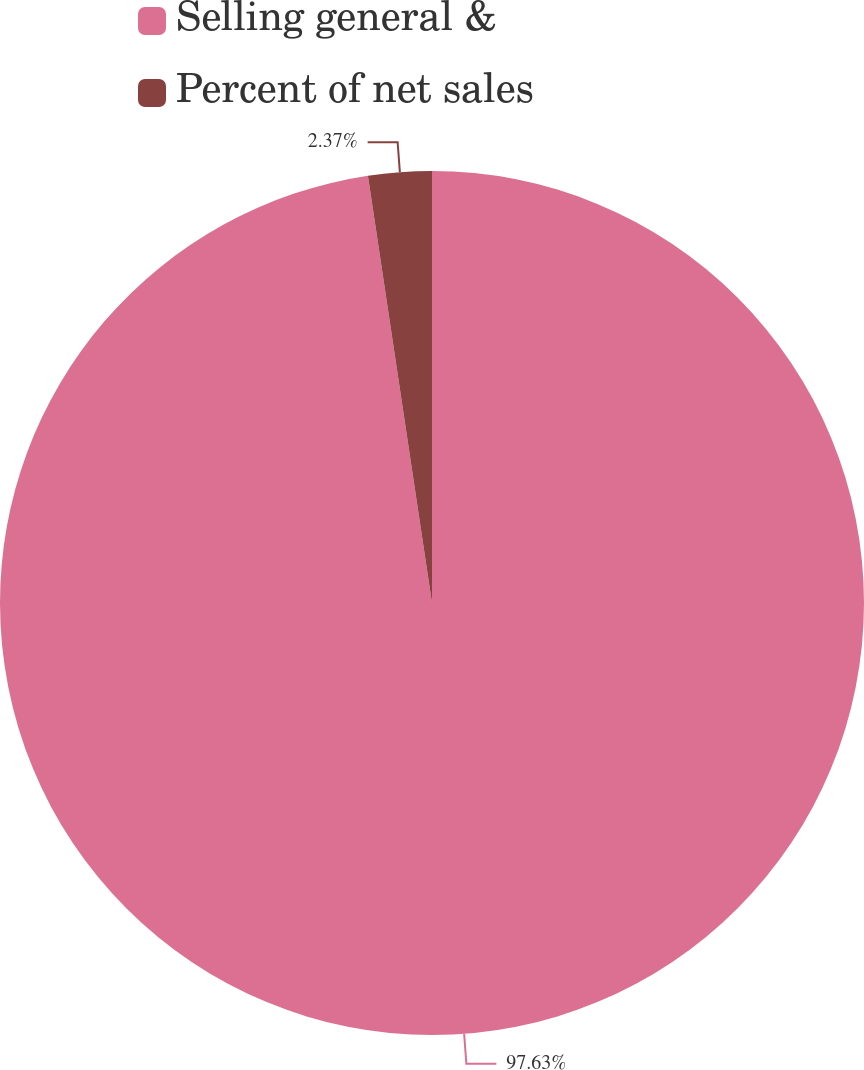<chart> <loc_0><loc_0><loc_500><loc_500><pie_chart><fcel>Selling general &<fcel>Percent of net sales<nl><fcel>97.63%<fcel>2.37%<nl></chart> 